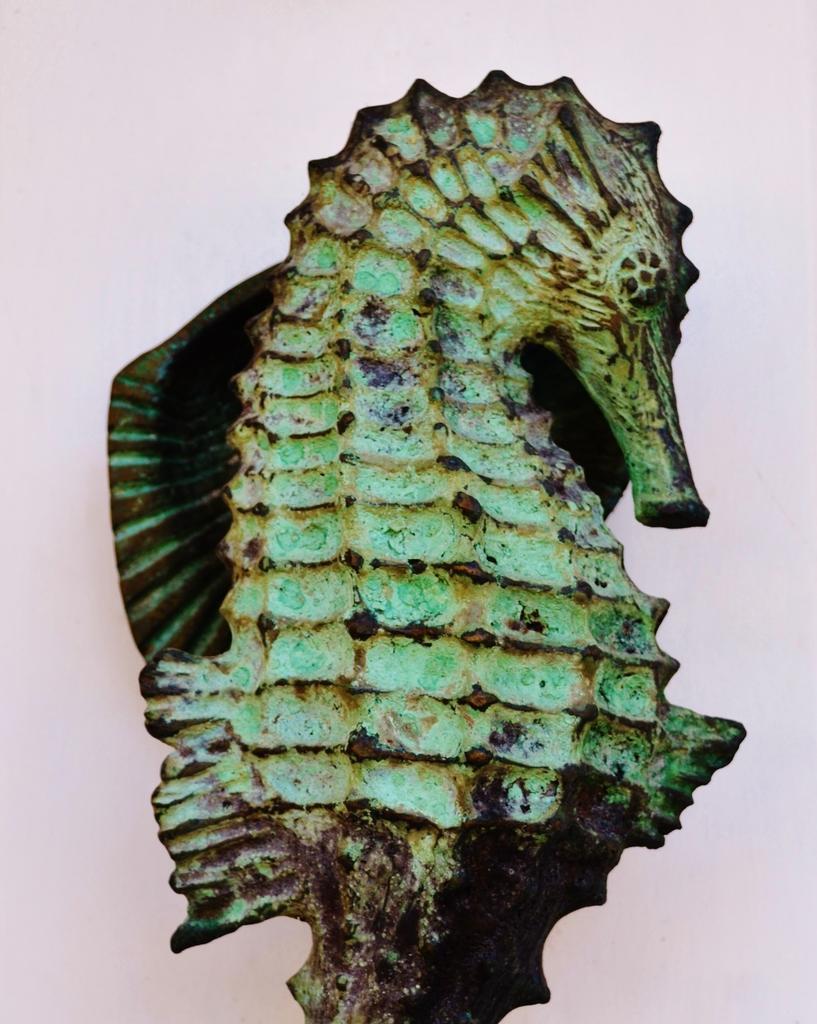Can you describe this image briefly? In this picture we can see a sculpture of seahorse. 